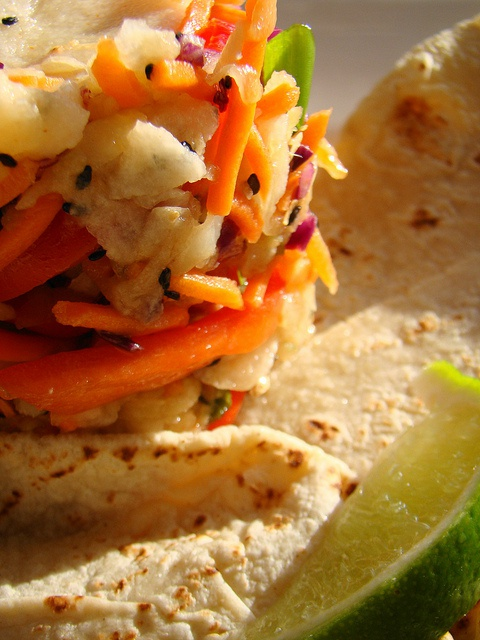Describe the objects in this image and their specific colors. I can see carrot in tan, maroon, and red tones, carrot in tan, red, and orange tones, carrot in tan, maroon, and black tones, carrot in tan, maroon, and black tones, and carrot in tan, maroon, and brown tones in this image. 